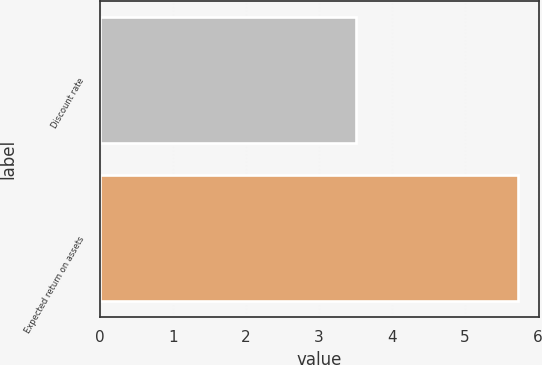Convert chart to OTSL. <chart><loc_0><loc_0><loc_500><loc_500><bar_chart><fcel>Discount rate<fcel>Expected return on assets<nl><fcel>3.51<fcel>5.73<nl></chart> 